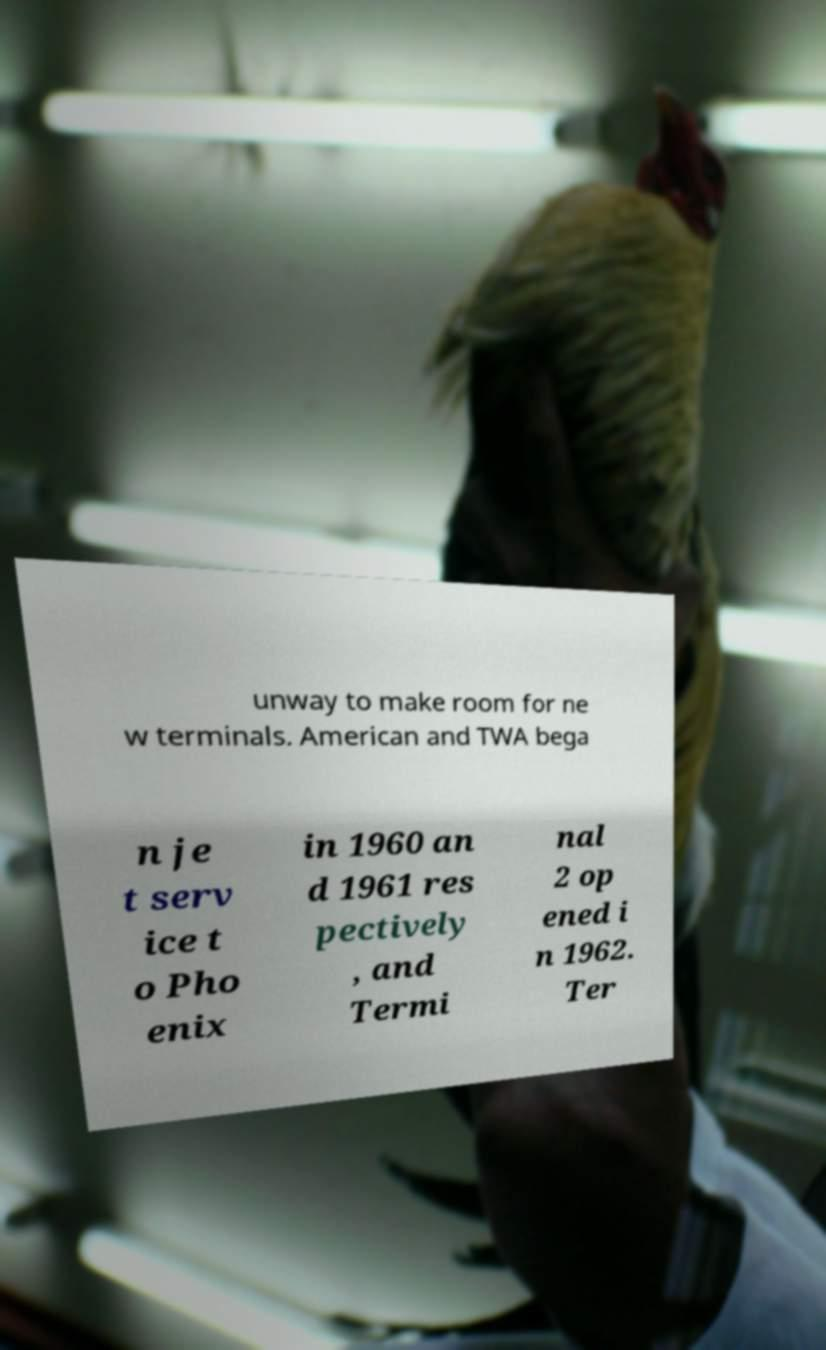I need the written content from this picture converted into text. Can you do that? unway to make room for ne w terminals. American and TWA bega n je t serv ice t o Pho enix in 1960 an d 1961 res pectively , and Termi nal 2 op ened i n 1962. Ter 